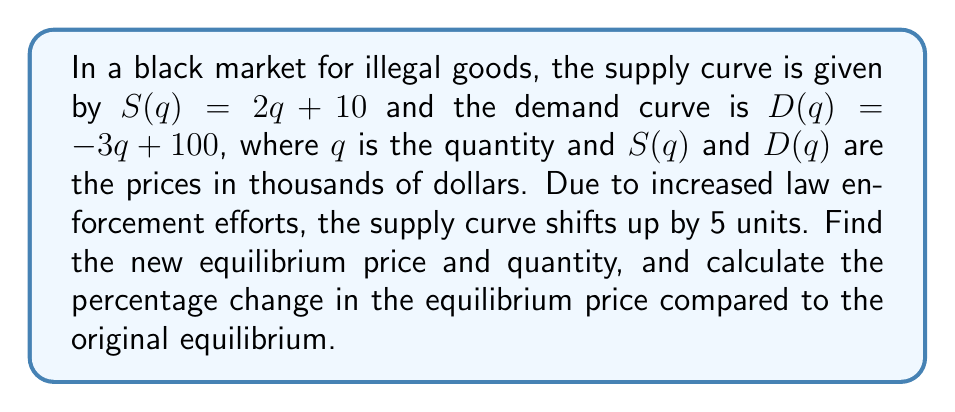Teach me how to tackle this problem. 1) First, find the original equilibrium point:
   Set $S(q) = D(q)$
   $2q + 10 = -3q + 100$
   $5q = 90$
   $q = 18$
   Equilibrium quantity: 18 units
   Equilibrium price: $S(18) = 2(18) + 10 = 46$ thousand dollars

2) New supply curve after shift:
   $S_{new}(q) = 2q + 15$

3) Find new equilibrium:
   $S_{new}(q) = D(q)$
   $2q + 15 = -3q + 100$
   $5q = 85$
   $q = 17$
   New equilibrium quantity: 17 units
   New equilibrium price: $S_{new}(17) = 2(17) + 15 = 49$ thousand dollars

4) Calculate percentage change in price:
   Percentage change = $\frac{\text{New price} - \text{Original price}}{\text{Original price}} \times 100\%$
   $= \frac{49 - 46}{46} \times 100\% = \frac{3}{46} \times 100\% \approx 6.52\%$
Answer: New equilibrium: 17 units at $49,000; Price increased by 6.52% 